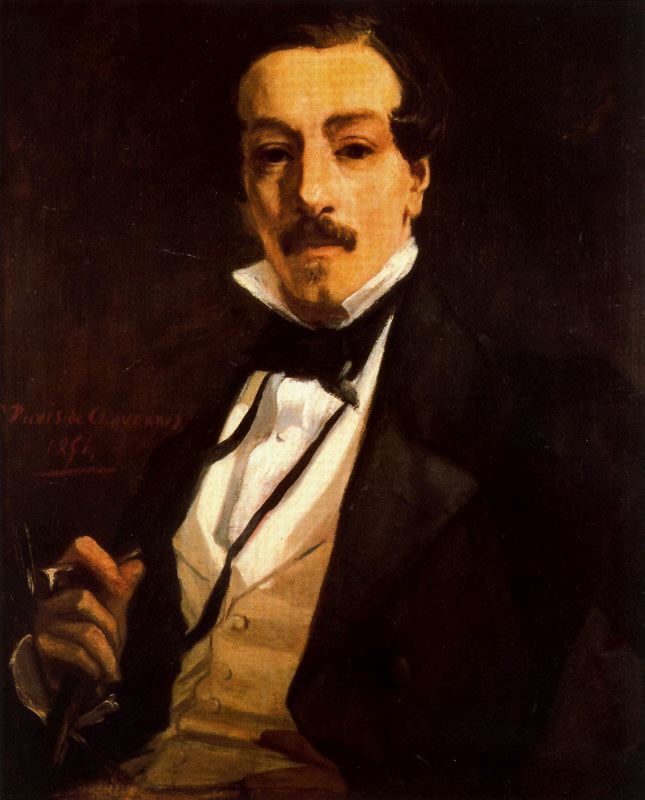Imagine this portrait could tell a story. What story might it tell? If this portrait could tell a story, it might be the tale of an enigmatic writer. The man, impeccably dressed in his formal attire, could be a distinguished author in the throes of composing a masterpiece. His pensive expression and the pen he holds suggest that he is deep in thought, possibly contemplating the next twist in his narrative or the perfect phrase to capture his ideas. Set against a backdrop of deep, moody colors, the scene evokes a moment of intense creativity and introspection. Perhaps he has just returned from a high-society event, inspired by the conversations and characters he encountered, and now finds himself lost in the world he's creating on the pages before him. What might be happening around the subject that we cannot see? Outside the frame of the portrait, one might imagine a richly adorned study filled with books, papers, and artifacts of intellectual pursuit. The writer's desk, likely cluttered with manuscripts, ink bottles, and quills, bears the signs of countless hours of labor and thought. Perhaps a fireplace casts a warm, flickering glow across the room, adding to the air of quiet contemplation. There might be personal memorabilia, such as letters from admirers or correspondence with other literary figures, scattered about. The ambiance is one of solitude and reverie, where the man delves deep into his imagination, undisturbed by the outside world. 